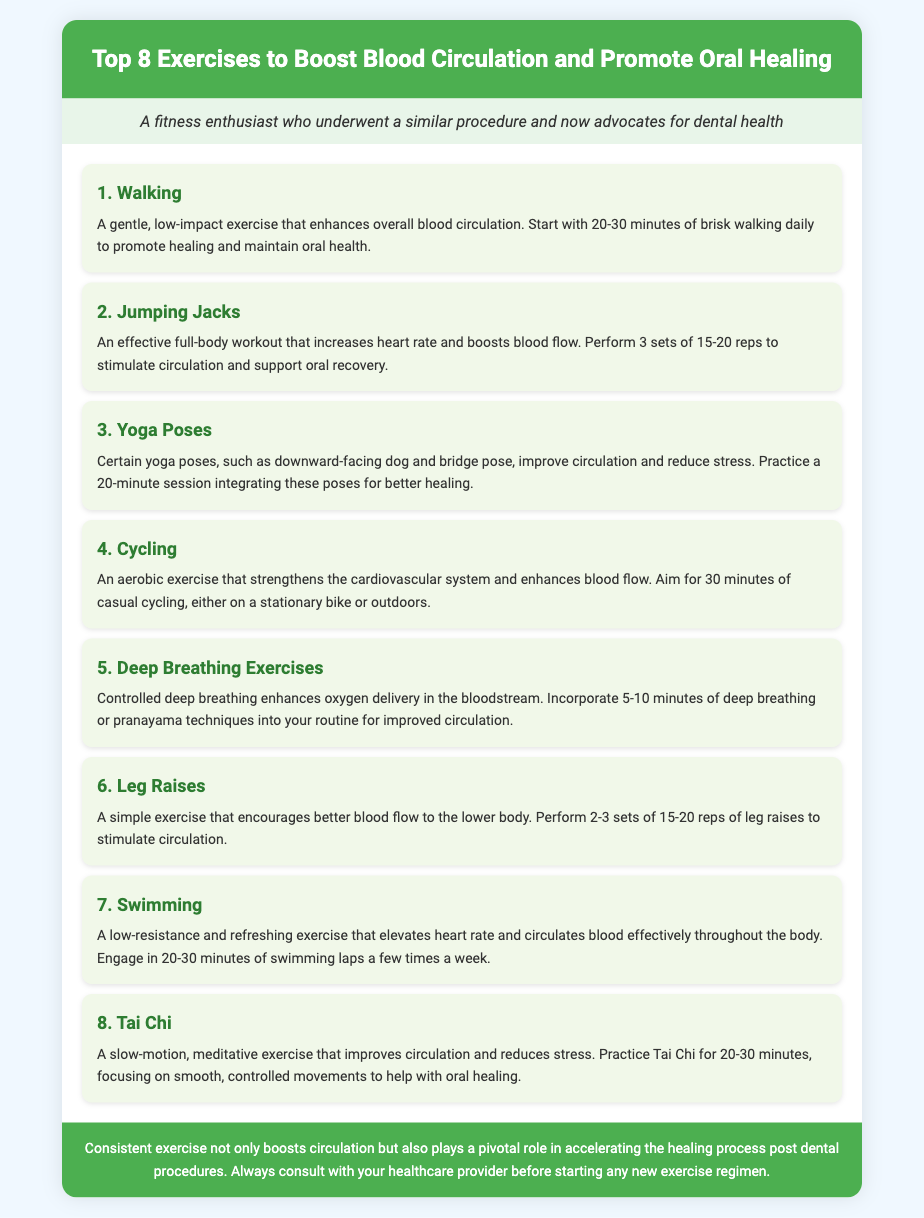What is the title of the document? The title of the document is stated in the header section.
Answer: Top 8 Exercises to Boost Blood Circulation and Promote Oral Healing How many exercises are listed in the document? The number of exercises is indicated in the title and summarized in the list.
Answer: 8 What is the first exercise mentioned? The first exercise is listed at the top of the exercise list.
Answer: Walking How long should one perform yoga poses for better healing? The recommended duration for yoga poses is mentioned in the exercise description.
Answer: 20 minutes What type of exercise is swimming classified as? The document classifies swimming based on its effects on circulation and resistance.
Answer: Low-resistance Which exercise involves controlled deep breathing? The exercise explicitly named for controlled deep breathing is included in the list.
Answer: Deep Breathing Exercises What is the suggested duration for casual cycling? The duration for casual cycling is detailed in the corresponding exercise description.
Answer: 30 minutes Which exercise focuses on smooth, controlled movements? The exercise that emphasizes smooth and controlled movements is specified in the description.
Answer: Tai Chi 